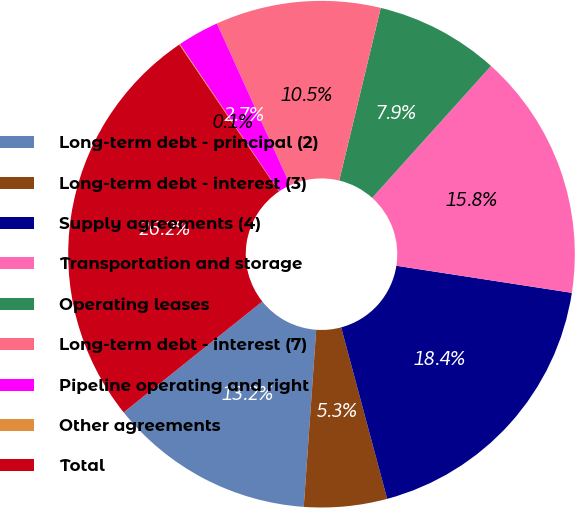Convert chart. <chart><loc_0><loc_0><loc_500><loc_500><pie_chart><fcel>Long-term debt - principal (2)<fcel>Long-term debt - interest (3)<fcel>Supply agreements (4)<fcel>Transportation and storage<fcel>Operating leases<fcel>Long-term debt - interest (7)<fcel>Pipeline operating and right<fcel>Other agreements<fcel>Total<nl><fcel>13.15%<fcel>5.29%<fcel>18.39%<fcel>15.77%<fcel>7.91%<fcel>10.53%<fcel>2.67%<fcel>0.05%<fcel>26.24%<nl></chart> 